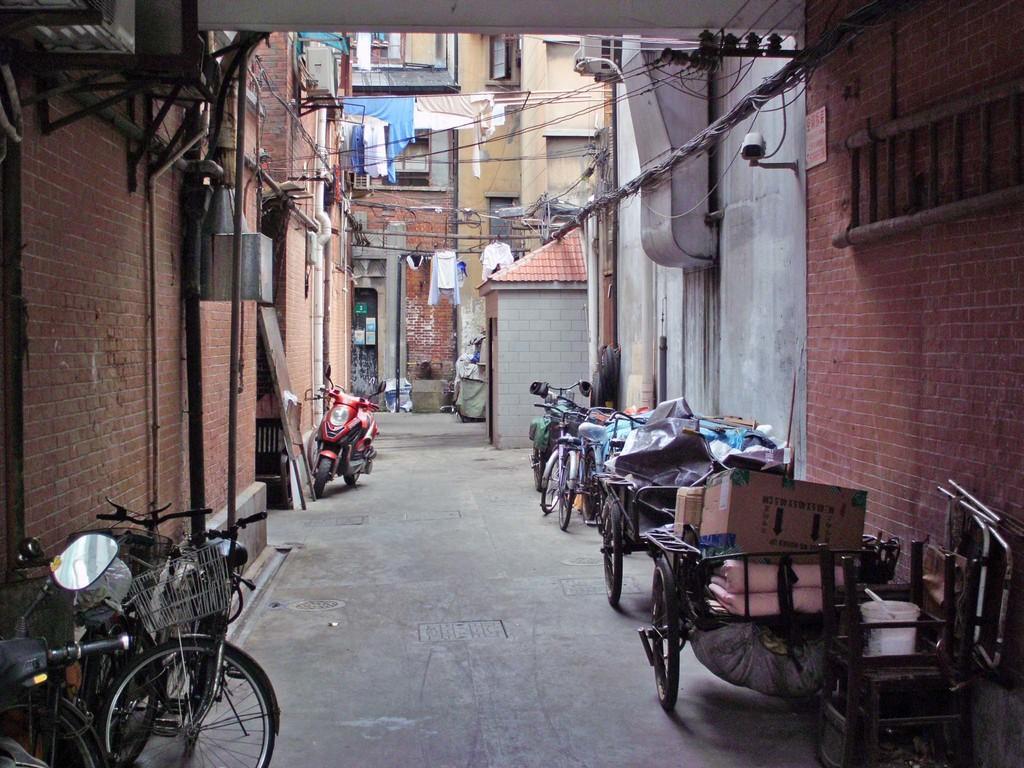Please provide a concise description of this image. This picture might be taken from outside of the building. In this image, on the right side, we can see a brick wall, ladder, camera, electric pole, electric wires, vehicles. On the left side, we can also see a brick wall, few motorbikes, air conditioner. In the background, we can see some clothes, electric wires, building, glass window. At the bottom, we can see a land. 